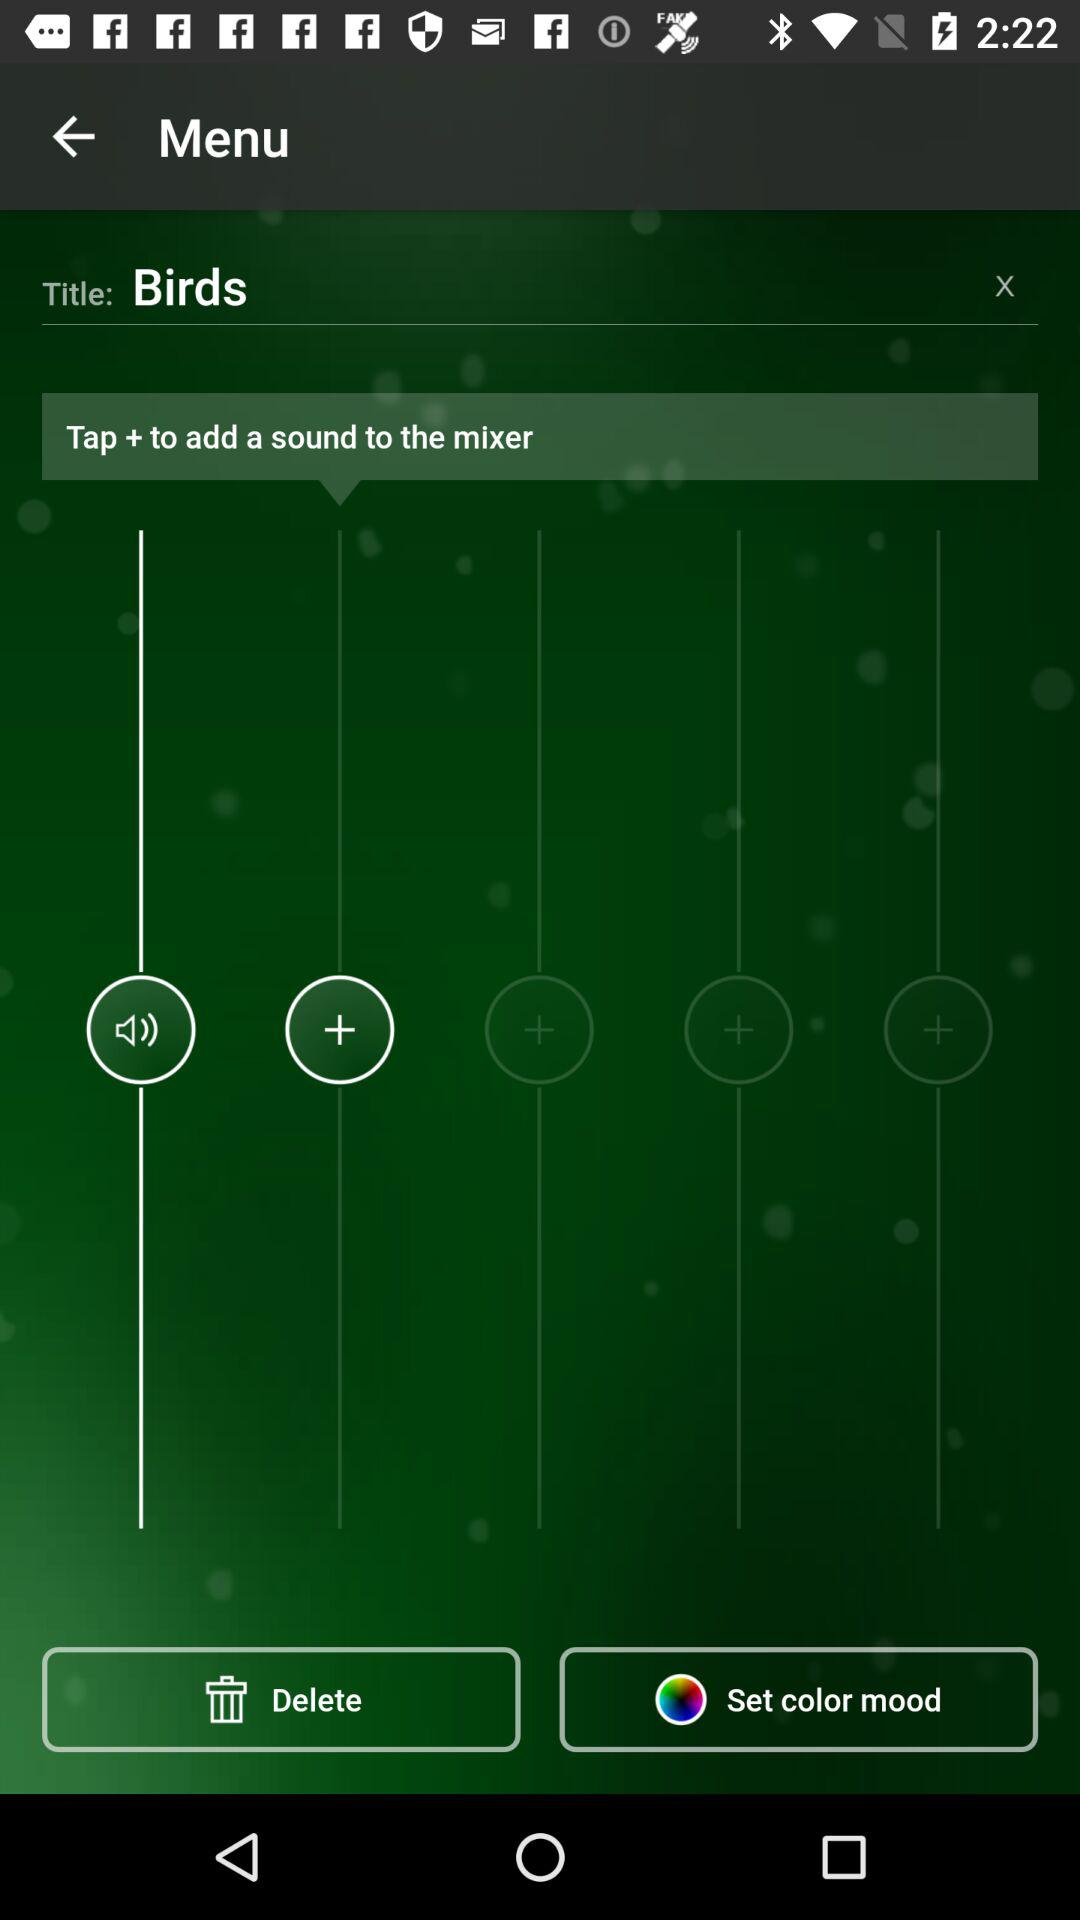What is the title? The title is "Birds". 